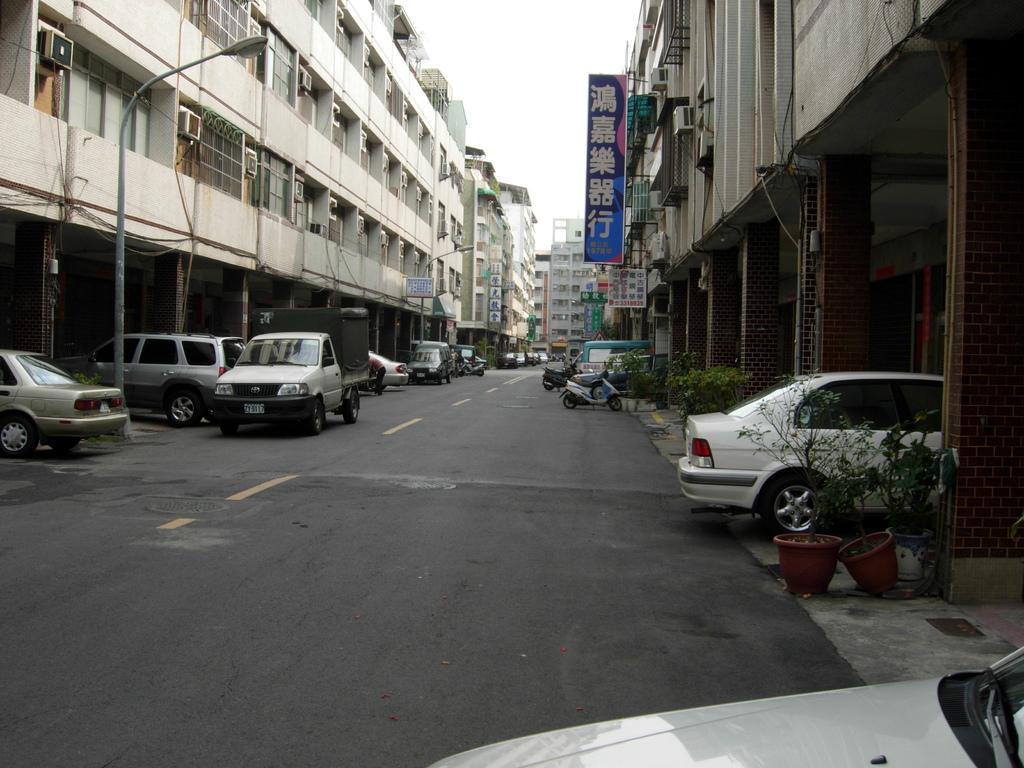Can you describe this image briefly? In the center of the image there is a road. There are vehicles on the road. To the both sides of the image there are buildings. There is a street light. There are plants. 